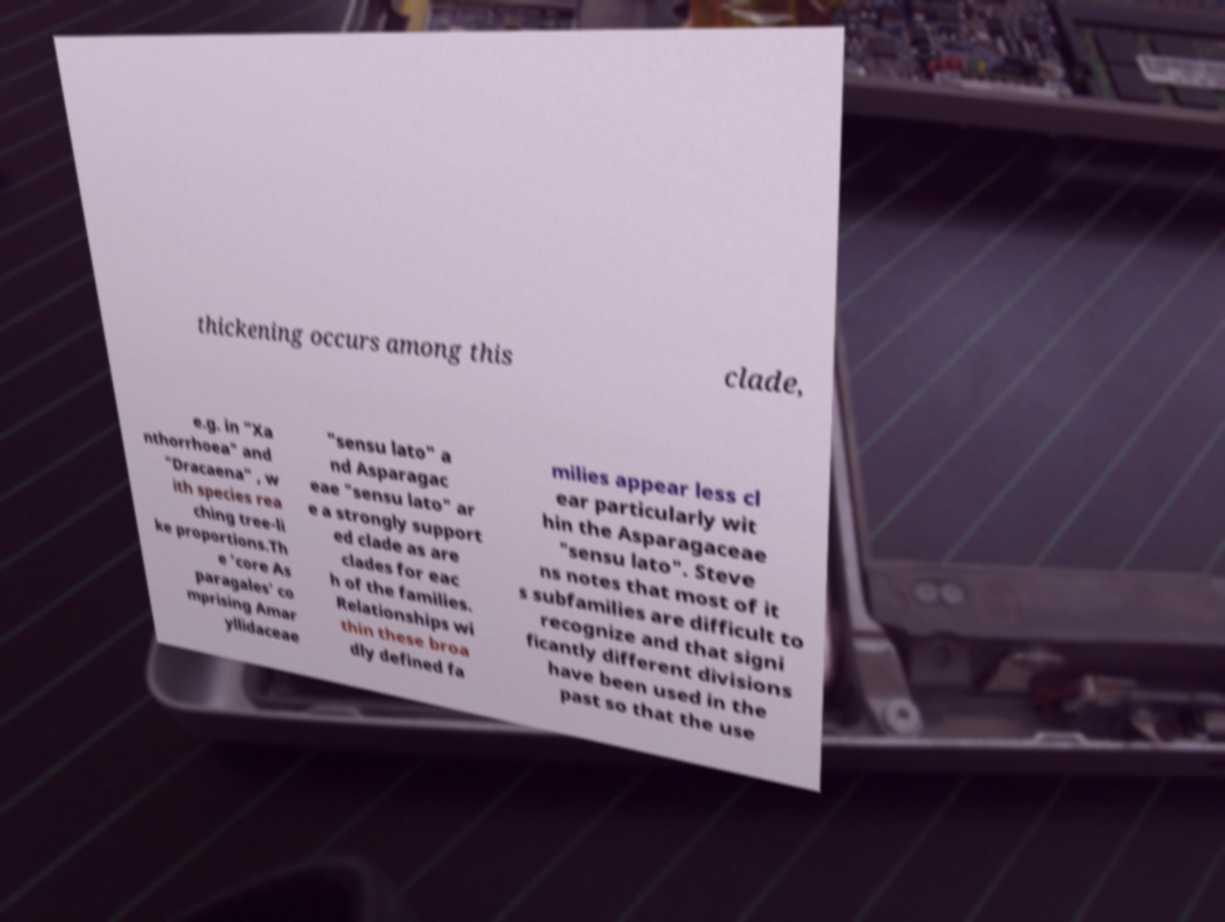What messages or text are displayed in this image? I need them in a readable, typed format. thickening occurs among this clade, e.g. in "Xa nthorrhoea" and "Dracaena" , w ith species rea ching tree-li ke proportions.Th e 'core As paragales' co mprising Amar yllidaceae "sensu lato" a nd Asparagac eae "sensu lato" ar e a strongly support ed clade as are clades for eac h of the families. Relationships wi thin these broa dly defined fa milies appear less cl ear particularly wit hin the Asparagaceae "sensu lato". Steve ns notes that most of it s subfamilies are difficult to recognize and that signi ficantly different divisions have been used in the past so that the use 